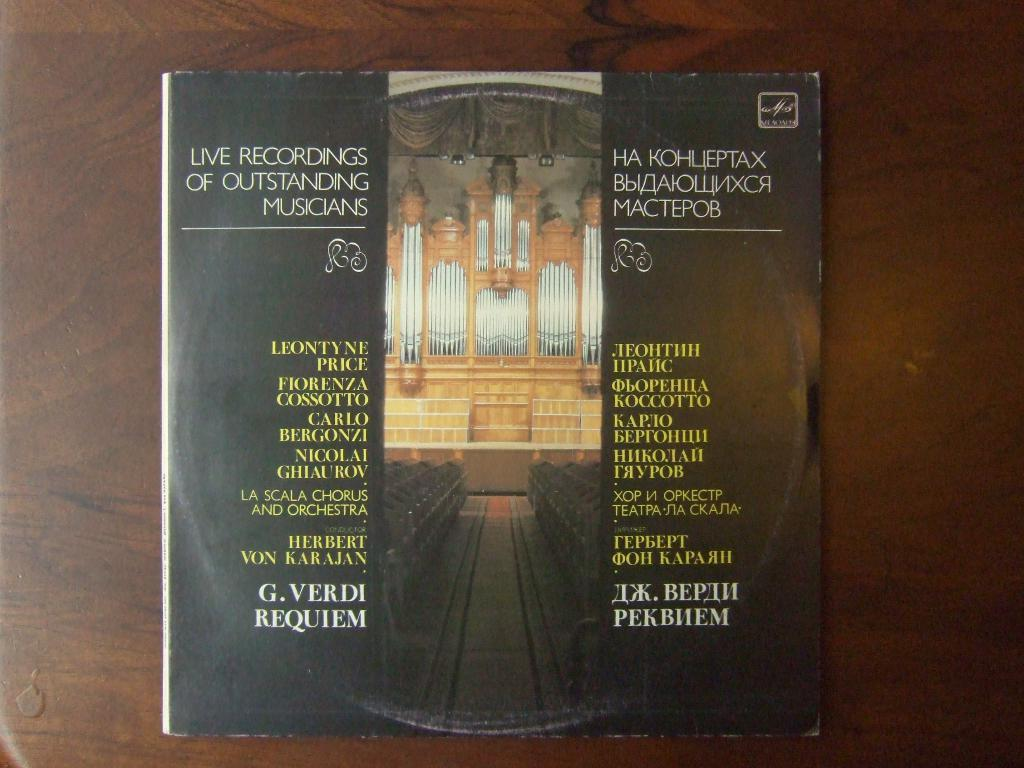<image>
Describe the image concisely. a book about Live Recordings of Outstanding Musicians 